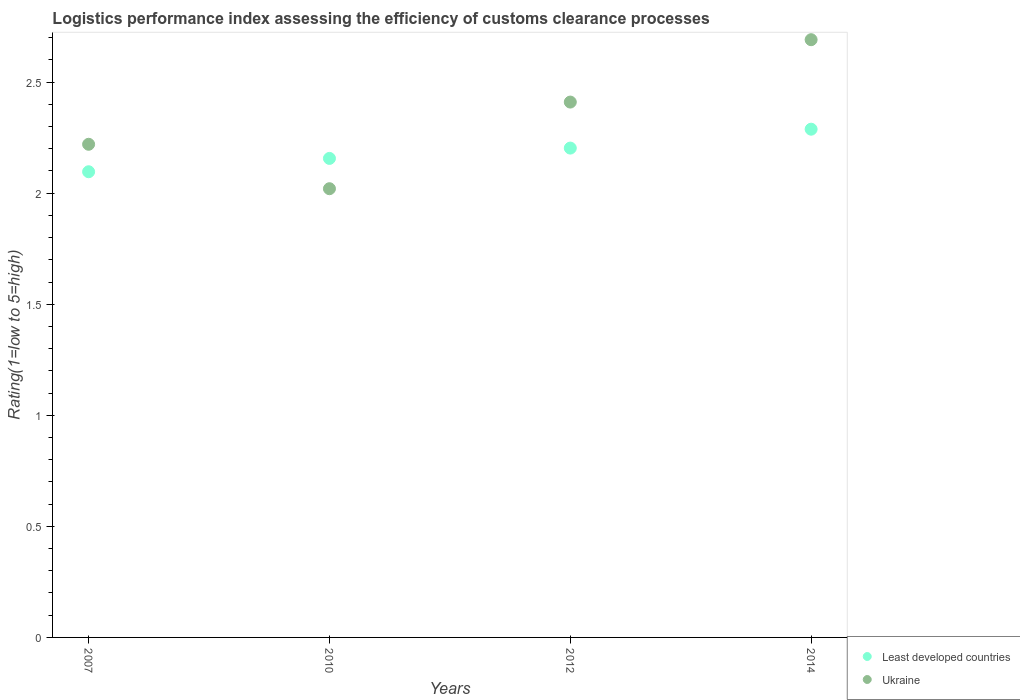How many different coloured dotlines are there?
Make the answer very short. 2. What is the Logistic performance index in Least developed countries in 2012?
Offer a terse response. 2.2. Across all years, what is the maximum Logistic performance index in Least developed countries?
Make the answer very short. 2.29. Across all years, what is the minimum Logistic performance index in Least developed countries?
Make the answer very short. 2.1. What is the total Logistic performance index in Ukraine in the graph?
Provide a succinct answer. 9.34. What is the difference between the Logistic performance index in Least developed countries in 2007 and that in 2014?
Keep it short and to the point. -0.19. What is the difference between the Logistic performance index in Ukraine in 2010 and the Logistic performance index in Least developed countries in 2012?
Offer a terse response. -0.18. What is the average Logistic performance index in Ukraine per year?
Make the answer very short. 2.34. In the year 2007, what is the difference between the Logistic performance index in Ukraine and Logistic performance index in Least developed countries?
Your answer should be compact. 0.12. In how many years, is the Logistic performance index in Least developed countries greater than 0.4?
Make the answer very short. 4. What is the ratio of the Logistic performance index in Ukraine in 2010 to that in 2014?
Offer a very short reply. 0.75. What is the difference between the highest and the second highest Logistic performance index in Least developed countries?
Offer a terse response. 0.09. What is the difference between the highest and the lowest Logistic performance index in Least developed countries?
Provide a succinct answer. 0.19. Is the sum of the Logistic performance index in Least developed countries in 2007 and 2010 greater than the maximum Logistic performance index in Ukraine across all years?
Keep it short and to the point. Yes. Is the Logistic performance index in Ukraine strictly greater than the Logistic performance index in Least developed countries over the years?
Offer a very short reply. No. Is the Logistic performance index in Least developed countries strictly less than the Logistic performance index in Ukraine over the years?
Give a very brief answer. No. How many dotlines are there?
Ensure brevity in your answer.  2. How many years are there in the graph?
Your answer should be compact. 4. Does the graph contain any zero values?
Provide a short and direct response. No. How many legend labels are there?
Offer a terse response. 2. What is the title of the graph?
Provide a short and direct response. Logistics performance index assessing the efficiency of customs clearance processes. What is the label or title of the X-axis?
Provide a succinct answer. Years. What is the label or title of the Y-axis?
Provide a succinct answer. Rating(1=low to 5=high). What is the Rating(1=low to 5=high) in Least developed countries in 2007?
Give a very brief answer. 2.1. What is the Rating(1=low to 5=high) in Ukraine in 2007?
Ensure brevity in your answer.  2.22. What is the Rating(1=low to 5=high) of Least developed countries in 2010?
Your response must be concise. 2.16. What is the Rating(1=low to 5=high) of Ukraine in 2010?
Give a very brief answer. 2.02. What is the Rating(1=low to 5=high) in Least developed countries in 2012?
Make the answer very short. 2.2. What is the Rating(1=low to 5=high) in Ukraine in 2012?
Provide a succinct answer. 2.41. What is the Rating(1=low to 5=high) of Least developed countries in 2014?
Keep it short and to the point. 2.29. What is the Rating(1=low to 5=high) of Ukraine in 2014?
Your answer should be very brief. 2.69. Across all years, what is the maximum Rating(1=low to 5=high) in Least developed countries?
Make the answer very short. 2.29. Across all years, what is the maximum Rating(1=low to 5=high) of Ukraine?
Provide a succinct answer. 2.69. Across all years, what is the minimum Rating(1=low to 5=high) of Least developed countries?
Keep it short and to the point. 2.1. Across all years, what is the minimum Rating(1=low to 5=high) in Ukraine?
Ensure brevity in your answer.  2.02. What is the total Rating(1=low to 5=high) of Least developed countries in the graph?
Your response must be concise. 8.74. What is the total Rating(1=low to 5=high) in Ukraine in the graph?
Keep it short and to the point. 9.34. What is the difference between the Rating(1=low to 5=high) of Least developed countries in 2007 and that in 2010?
Offer a very short reply. -0.06. What is the difference between the Rating(1=low to 5=high) in Ukraine in 2007 and that in 2010?
Give a very brief answer. 0.2. What is the difference between the Rating(1=low to 5=high) in Least developed countries in 2007 and that in 2012?
Make the answer very short. -0.11. What is the difference between the Rating(1=low to 5=high) of Ukraine in 2007 and that in 2012?
Give a very brief answer. -0.19. What is the difference between the Rating(1=low to 5=high) of Least developed countries in 2007 and that in 2014?
Ensure brevity in your answer.  -0.19. What is the difference between the Rating(1=low to 5=high) in Ukraine in 2007 and that in 2014?
Your answer should be very brief. -0.47. What is the difference between the Rating(1=low to 5=high) in Least developed countries in 2010 and that in 2012?
Offer a very short reply. -0.05. What is the difference between the Rating(1=low to 5=high) of Ukraine in 2010 and that in 2012?
Your answer should be very brief. -0.39. What is the difference between the Rating(1=low to 5=high) of Least developed countries in 2010 and that in 2014?
Keep it short and to the point. -0.13. What is the difference between the Rating(1=low to 5=high) in Ukraine in 2010 and that in 2014?
Your response must be concise. -0.67. What is the difference between the Rating(1=low to 5=high) of Least developed countries in 2012 and that in 2014?
Make the answer very short. -0.09. What is the difference between the Rating(1=low to 5=high) of Ukraine in 2012 and that in 2014?
Ensure brevity in your answer.  -0.28. What is the difference between the Rating(1=low to 5=high) in Least developed countries in 2007 and the Rating(1=low to 5=high) in Ukraine in 2010?
Offer a terse response. 0.08. What is the difference between the Rating(1=low to 5=high) of Least developed countries in 2007 and the Rating(1=low to 5=high) of Ukraine in 2012?
Your response must be concise. -0.31. What is the difference between the Rating(1=low to 5=high) of Least developed countries in 2007 and the Rating(1=low to 5=high) of Ukraine in 2014?
Your answer should be compact. -0.59. What is the difference between the Rating(1=low to 5=high) in Least developed countries in 2010 and the Rating(1=low to 5=high) in Ukraine in 2012?
Offer a very short reply. -0.25. What is the difference between the Rating(1=low to 5=high) of Least developed countries in 2010 and the Rating(1=low to 5=high) of Ukraine in 2014?
Your response must be concise. -0.53. What is the difference between the Rating(1=low to 5=high) of Least developed countries in 2012 and the Rating(1=low to 5=high) of Ukraine in 2014?
Your answer should be compact. -0.49. What is the average Rating(1=low to 5=high) of Least developed countries per year?
Provide a short and direct response. 2.19. What is the average Rating(1=low to 5=high) in Ukraine per year?
Provide a short and direct response. 2.34. In the year 2007, what is the difference between the Rating(1=low to 5=high) of Least developed countries and Rating(1=low to 5=high) of Ukraine?
Your answer should be very brief. -0.12. In the year 2010, what is the difference between the Rating(1=low to 5=high) in Least developed countries and Rating(1=low to 5=high) in Ukraine?
Provide a succinct answer. 0.14. In the year 2012, what is the difference between the Rating(1=low to 5=high) of Least developed countries and Rating(1=low to 5=high) of Ukraine?
Your response must be concise. -0.21. In the year 2014, what is the difference between the Rating(1=low to 5=high) in Least developed countries and Rating(1=low to 5=high) in Ukraine?
Give a very brief answer. -0.4. What is the ratio of the Rating(1=low to 5=high) of Least developed countries in 2007 to that in 2010?
Make the answer very short. 0.97. What is the ratio of the Rating(1=low to 5=high) of Ukraine in 2007 to that in 2010?
Offer a terse response. 1.1. What is the ratio of the Rating(1=low to 5=high) of Least developed countries in 2007 to that in 2012?
Make the answer very short. 0.95. What is the ratio of the Rating(1=low to 5=high) of Ukraine in 2007 to that in 2012?
Offer a terse response. 0.92. What is the ratio of the Rating(1=low to 5=high) in Least developed countries in 2007 to that in 2014?
Make the answer very short. 0.92. What is the ratio of the Rating(1=low to 5=high) of Ukraine in 2007 to that in 2014?
Your response must be concise. 0.82. What is the ratio of the Rating(1=low to 5=high) in Least developed countries in 2010 to that in 2012?
Offer a very short reply. 0.98. What is the ratio of the Rating(1=low to 5=high) in Ukraine in 2010 to that in 2012?
Offer a very short reply. 0.84. What is the ratio of the Rating(1=low to 5=high) in Least developed countries in 2010 to that in 2014?
Ensure brevity in your answer.  0.94. What is the ratio of the Rating(1=low to 5=high) of Ukraine in 2010 to that in 2014?
Your answer should be very brief. 0.75. What is the ratio of the Rating(1=low to 5=high) of Least developed countries in 2012 to that in 2014?
Provide a short and direct response. 0.96. What is the ratio of the Rating(1=low to 5=high) of Ukraine in 2012 to that in 2014?
Ensure brevity in your answer.  0.9. What is the difference between the highest and the second highest Rating(1=low to 5=high) of Least developed countries?
Ensure brevity in your answer.  0.09. What is the difference between the highest and the second highest Rating(1=low to 5=high) of Ukraine?
Provide a succinct answer. 0.28. What is the difference between the highest and the lowest Rating(1=low to 5=high) of Least developed countries?
Offer a terse response. 0.19. What is the difference between the highest and the lowest Rating(1=low to 5=high) in Ukraine?
Your answer should be compact. 0.67. 